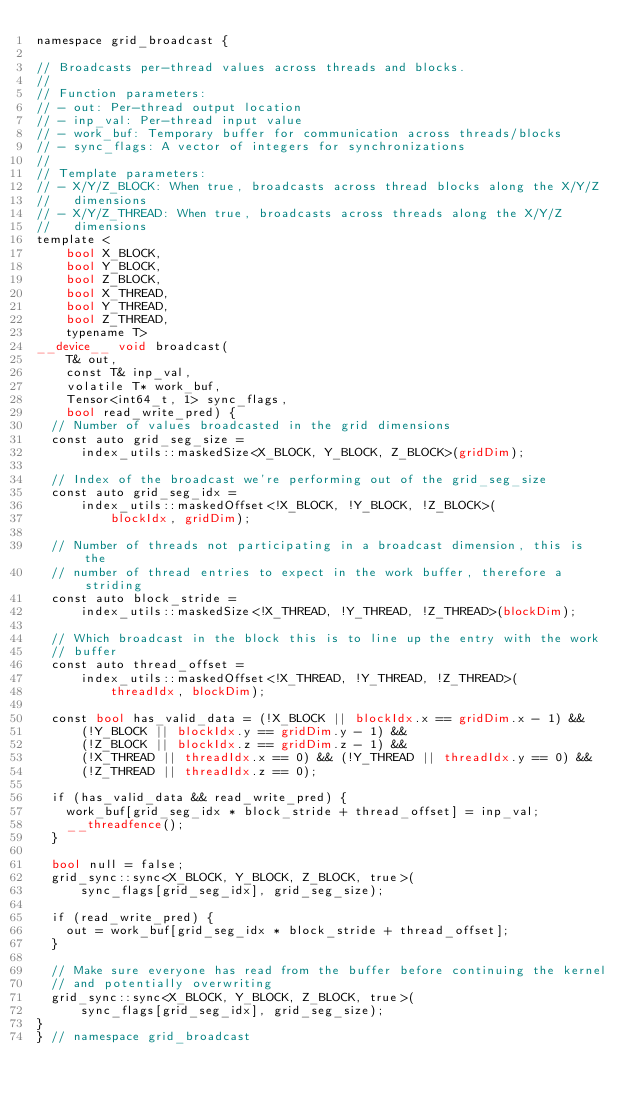Convert code to text. <code><loc_0><loc_0><loc_500><loc_500><_Cuda_>namespace grid_broadcast {

// Broadcasts per-thread values across threads and blocks.
//
// Function parameters:
// - out: Per-thread output location
// - inp_val: Per-thread input value
// - work_buf: Temporary buffer for communication across threads/blocks
// - sync_flags: A vector of integers for synchronizations
//
// Template parameters:
// - X/Y/Z_BLOCK: When true, broadcasts across thread blocks along the X/Y/Z
//   dimensions
// - X/Y/Z_THREAD: When true, broadcasts across threads along the X/Y/Z
//   dimensions
template <
    bool X_BLOCK,
    bool Y_BLOCK,
    bool Z_BLOCK,
    bool X_THREAD,
    bool Y_THREAD,
    bool Z_THREAD,
    typename T>
__device__ void broadcast(
    T& out,
    const T& inp_val,
    volatile T* work_buf,
    Tensor<int64_t, 1> sync_flags,
    bool read_write_pred) {
  // Number of values broadcasted in the grid dimensions
  const auto grid_seg_size =
      index_utils::maskedSize<X_BLOCK, Y_BLOCK, Z_BLOCK>(gridDim);

  // Index of the broadcast we're performing out of the grid_seg_size
  const auto grid_seg_idx =
      index_utils::maskedOffset<!X_BLOCK, !Y_BLOCK, !Z_BLOCK>(
          blockIdx, gridDim);

  // Number of threads not participating in a broadcast dimension, this is the
  // number of thread entries to expect in the work buffer, therefore a striding
  const auto block_stride =
      index_utils::maskedSize<!X_THREAD, !Y_THREAD, !Z_THREAD>(blockDim);

  // Which broadcast in the block this is to line up the entry with the work
  // buffer
  const auto thread_offset =
      index_utils::maskedOffset<!X_THREAD, !Y_THREAD, !Z_THREAD>(
          threadIdx, blockDim);

  const bool has_valid_data = (!X_BLOCK || blockIdx.x == gridDim.x - 1) &&
      (!Y_BLOCK || blockIdx.y == gridDim.y - 1) &&
      (!Z_BLOCK || blockIdx.z == gridDim.z - 1) &&
      (!X_THREAD || threadIdx.x == 0) && (!Y_THREAD || threadIdx.y == 0) &&
      (!Z_THREAD || threadIdx.z == 0);

  if (has_valid_data && read_write_pred) {
    work_buf[grid_seg_idx * block_stride + thread_offset] = inp_val;
    __threadfence();
  }

  bool null = false;
  grid_sync::sync<X_BLOCK, Y_BLOCK, Z_BLOCK, true>(
      sync_flags[grid_seg_idx], grid_seg_size);

  if (read_write_pred) {
    out = work_buf[grid_seg_idx * block_stride + thread_offset];
  }

  // Make sure everyone has read from the buffer before continuing the kernel
  // and potentially overwriting
  grid_sync::sync<X_BLOCK, Y_BLOCK, Z_BLOCK, true>(
      sync_flags[grid_seg_idx], grid_seg_size);
}
} // namespace grid_broadcast
</code> 